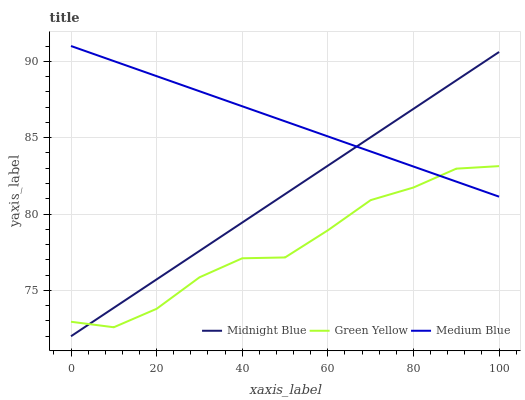Does Midnight Blue have the minimum area under the curve?
Answer yes or no. No. Does Midnight Blue have the maximum area under the curve?
Answer yes or no. No. Is Medium Blue the smoothest?
Answer yes or no. No. Is Medium Blue the roughest?
Answer yes or no. No. Does Medium Blue have the lowest value?
Answer yes or no. No. Does Midnight Blue have the highest value?
Answer yes or no. No. 